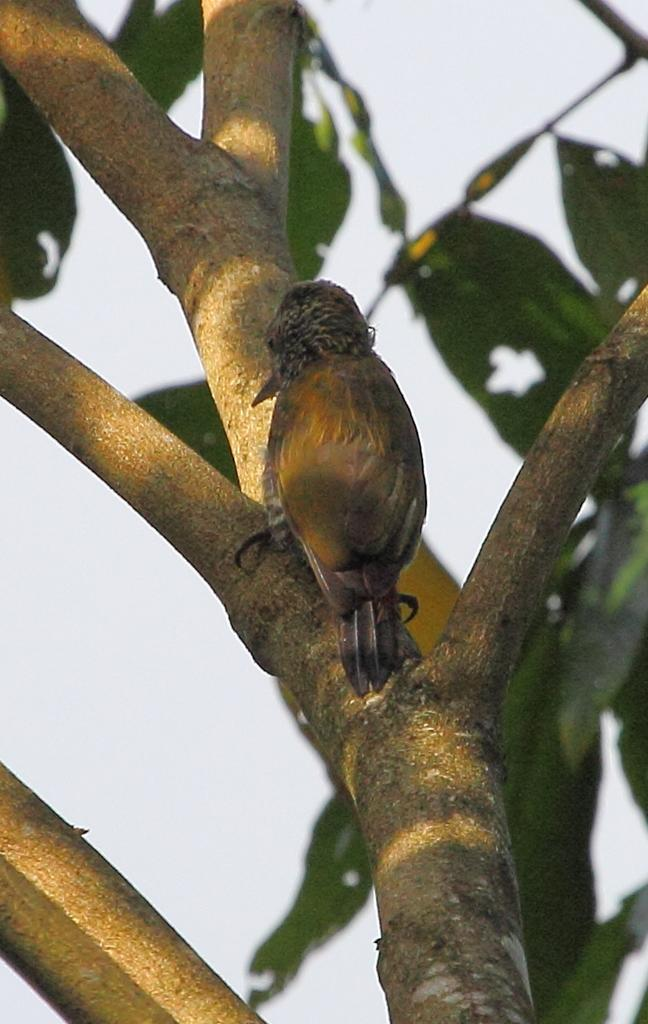What type of bird can be seen in the image? There is a brown color bird in the image. Where is the bird located? The bird is on a tree. What can be seen on the tree besides the bird? There are green leaves on the tree. What is visible at the top of the image? The sky is visible at the top of the image. How many beans are present in the image? There are no beans visible in the image. What type of fiction is the bird reading in the image? There is no indication that the bird is reading any fiction in the image. 